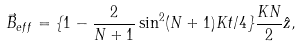<formula> <loc_0><loc_0><loc_500><loc_500>\vec { B } _ { e f f } = \{ 1 - \frac { 2 } { N + 1 } \sin ^ { 2 } ( N + 1 ) K t / 4 \} \frac { K N } { 2 } \hat { z } ,</formula> 